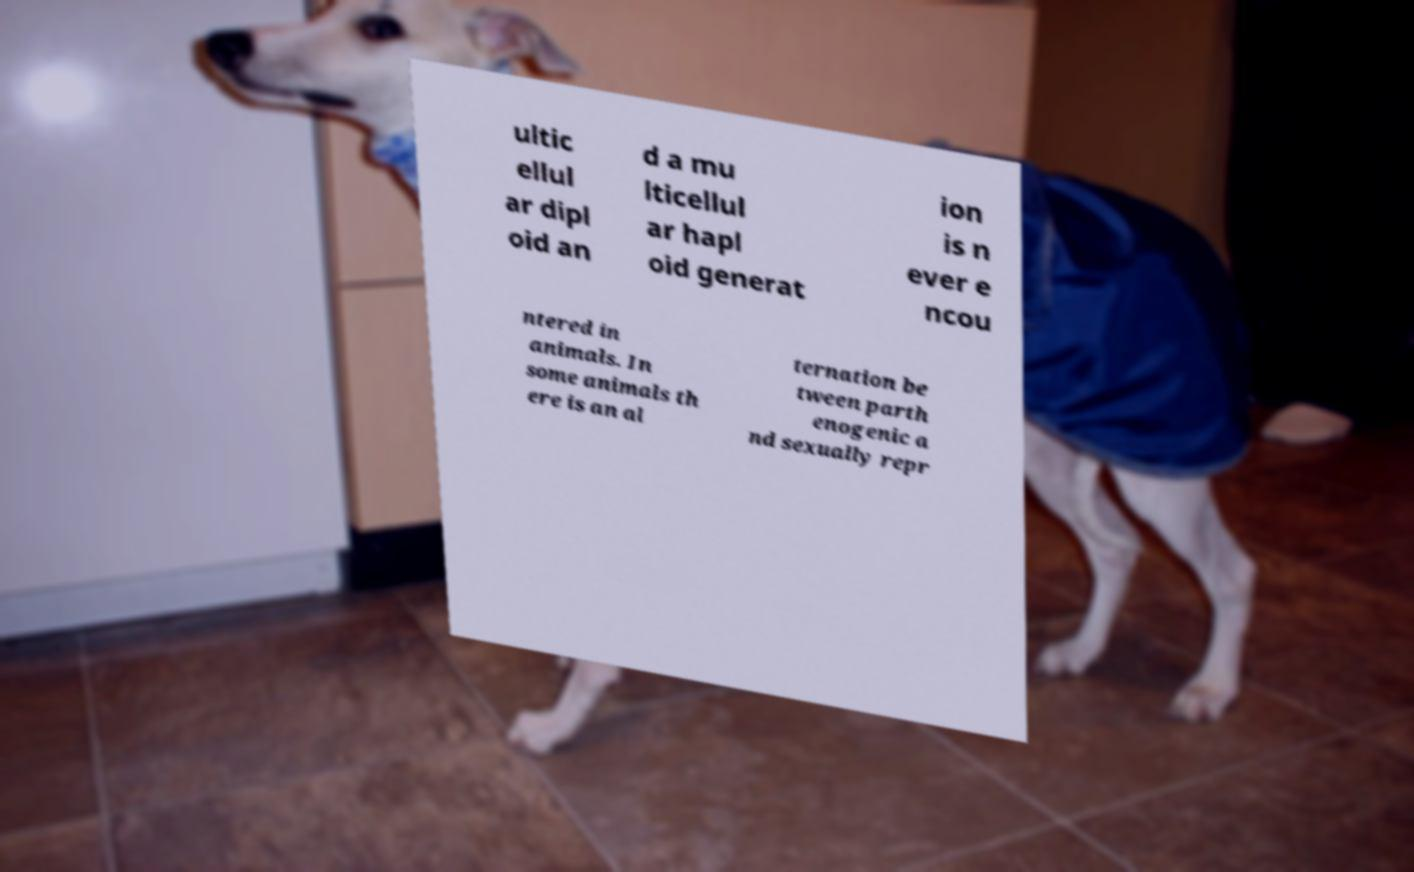Can you read and provide the text displayed in the image?This photo seems to have some interesting text. Can you extract and type it out for me? ultic ellul ar dipl oid an d a mu lticellul ar hapl oid generat ion is n ever e ncou ntered in animals. In some animals th ere is an al ternation be tween parth enogenic a nd sexually repr 